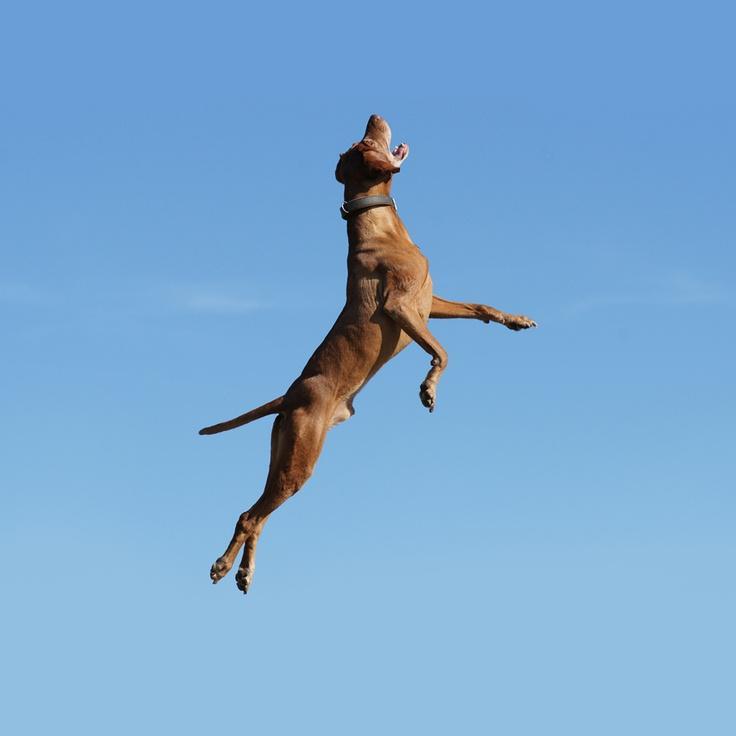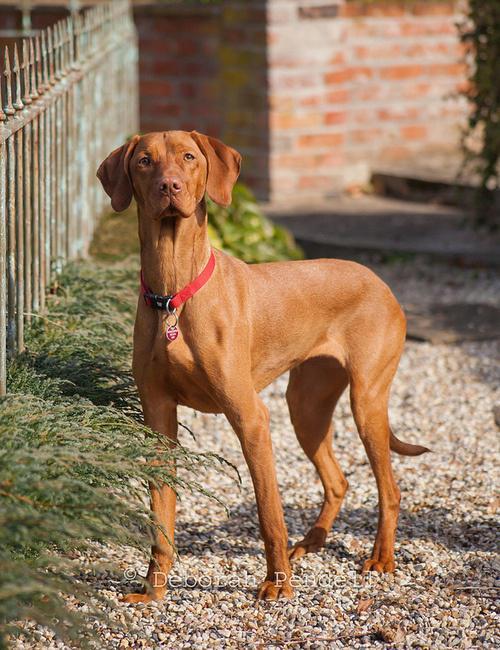The first image is the image on the left, the second image is the image on the right. Given the left and right images, does the statement "No more than two dogs are visible." hold true? Answer yes or no. Yes. The first image is the image on the left, the second image is the image on the right. Given the left and right images, does the statement "There are exactly two dogs." hold true? Answer yes or no. Yes. 